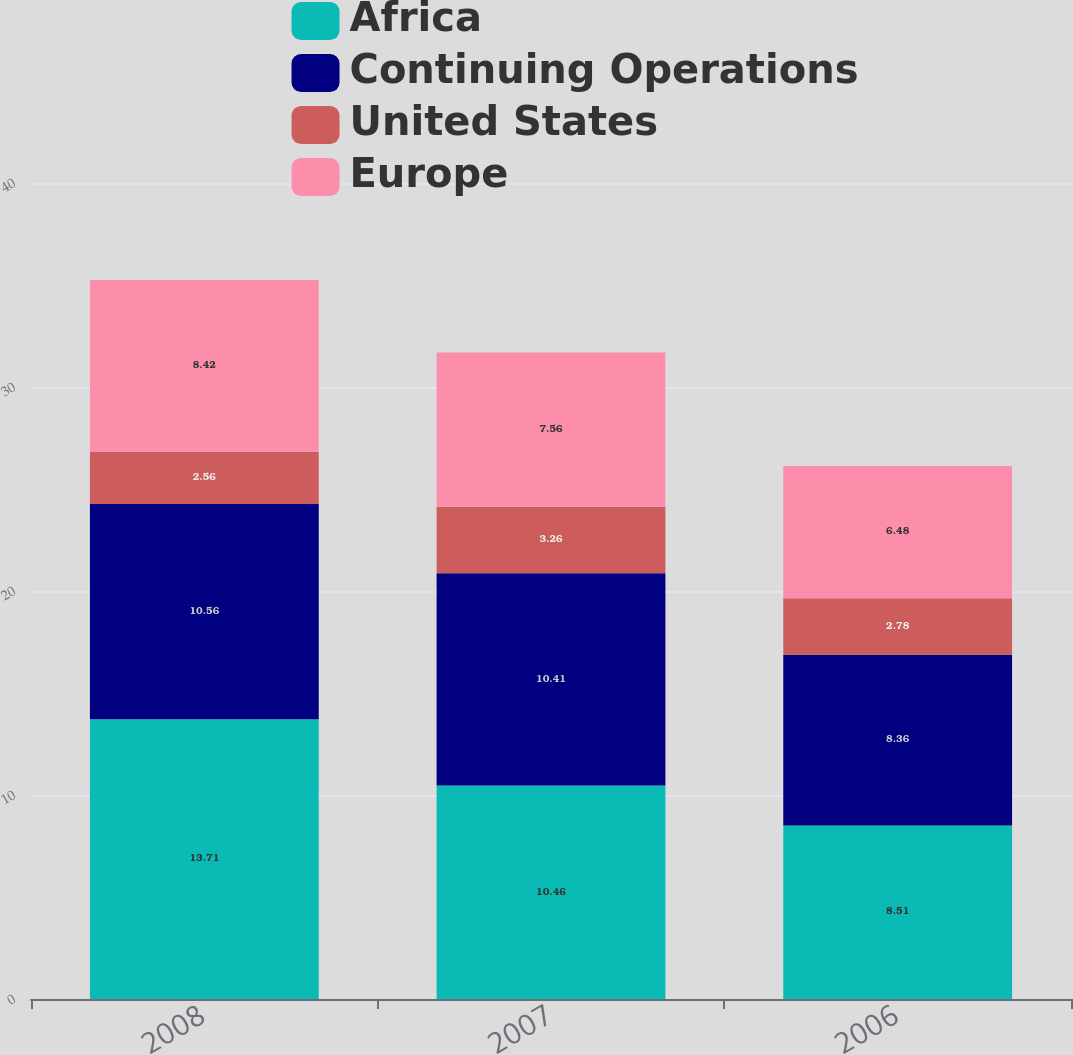Convert chart. <chart><loc_0><loc_0><loc_500><loc_500><stacked_bar_chart><ecel><fcel>2008<fcel>2007<fcel>2006<nl><fcel>Africa<fcel>13.71<fcel>10.46<fcel>8.51<nl><fcel>Continuing Operations<fcel>10.56<fcel>10.41<fcel>8.36<nl><fcel>United States<fcel>2.56<fcel>3.26<fcel>2.78<nl><fcel>Europe<fcel>8.42<fcel>7.56<fcel>6.48<nl></chart> 